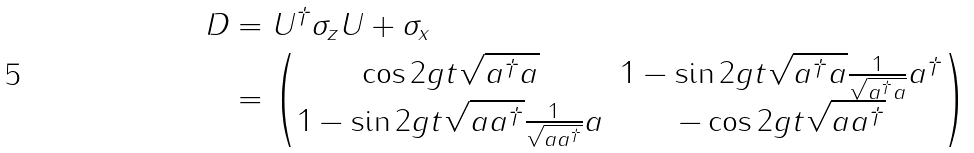<formula> <loc_0><loc_0><loc_500><loc_500>D & = U ^ { \dagger } \sigma _ { z } U + \sigma _ { x } \\ & = \begin{pmatrix} \cos 2 g t \sqrt { a ^ { \dagger } a } & 1 - \sin 2 g t \sqrt { a ^ { \dagger } a } \frac { 1 } { \sqrt { a ^ { \dagger } a } } a ^ { \dagger } \\ 1 - \sin 2 g t \sqrt { a a ^ { \dagger } } \frac { 1 } { \sqrt { a a ^ { \dagger } } } a & - \cos 2 g t \sqrt { a a ^ { \dagger } } \end{pmatrix}</formula> 